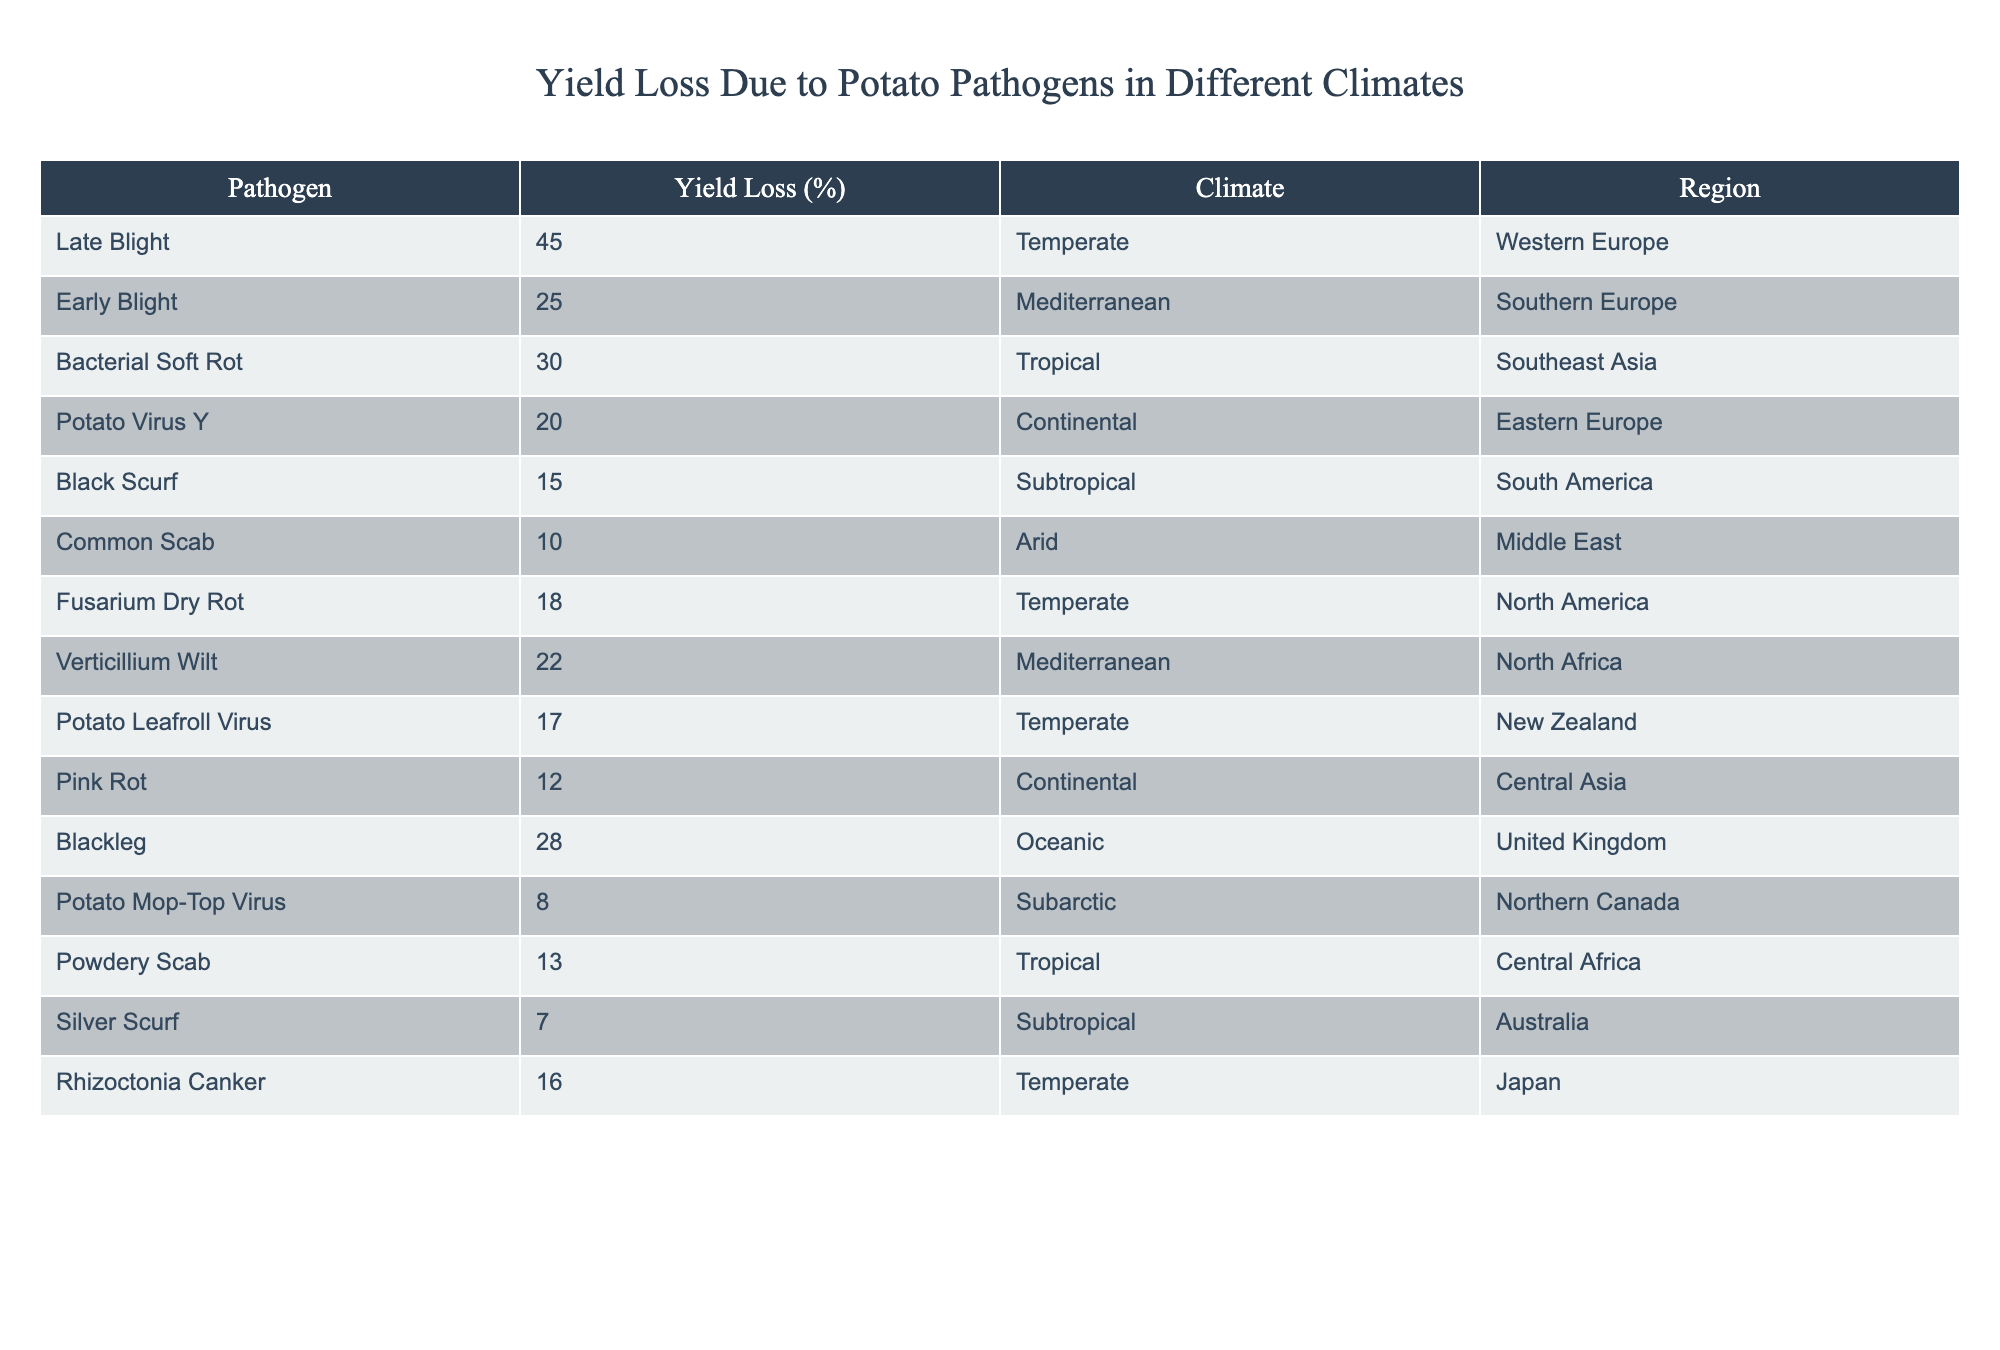What is the yield loss percentage caused by Late Blight? The table shows that Late Blight causes a yield loss of 45%.
Answer: 45% Which pathogen has the lowest yield loss, and what is that percentage? According to the table, Potato Mop-Top Virus has the lowest yield loss at 8%.
Answer: 8% What is the average yield loss from Tropical climate pathogens? The relevant pathogens in the Tropical climate are Bacterial Soft Rot (30%), Powdery Scab (13%), which gives a total of (30 + 13) = 43%. There are two pathogens, so the average is 43/2 = 21.5%.
Answer: 21.5% Is the yield loss due to Blackleg higher than that of Common Scab? The table shows Blackleg has a yield loss of 28% and Common Scab has 10%, so 28% is indeed higher than 10%.
Answer: Yes How much yield loss does Early Blight cause in comparison to Fusarium Dry Rot? Early Blight causes a yield loss of 25%, while Fusarium Dry Rot causes a loss of 18%. The difference is 25% - 18% = 7%.
Answer: 7% Which climate has the highest yield loss and what is the percentage? The Temperate climate has the highest yield loss from Late Blight at 45%.
Answer: 45% If we combine the yield loss percentages of Mediterranean pathogens, what would that be? The Mediterranean pathogens are Early Blight (25%) and Verticillium Wilt (22%). The total loss is 25% + 22% = 47%.
Answer: 47% Are there any pathogens in both Tropical and Subtropical climates that cause yield loss? The pathogens are Bacterial Soft Rot (Tropical) and Silver Scurf (Subtropical). While the yield loss percentages are present, these two are different pathogens. Thus, the answer is no, they don't overlap.
Answer: No What is the total yield loss from pathogens in the Temperate climate? The Temperate climate has three pathogens: Late Blight (45%), Fusarium Dry Rot (18%), and Potato Leafroll Virus (17%). Summing these gives a total of 45 + 18 + 17 = 80%.
Answer: 80% Which region has a yield loss due to pathogens that exceeds 25%? The regions with pathogens exceeding 25% include: Western Europe (Late Blight 45%), Southeast Asia (Bacterial Soft Rot 30%), and the United Kingdom (Blackleg 28%).
Answer: Western Europe, Southeast Asia, United Kingdom 